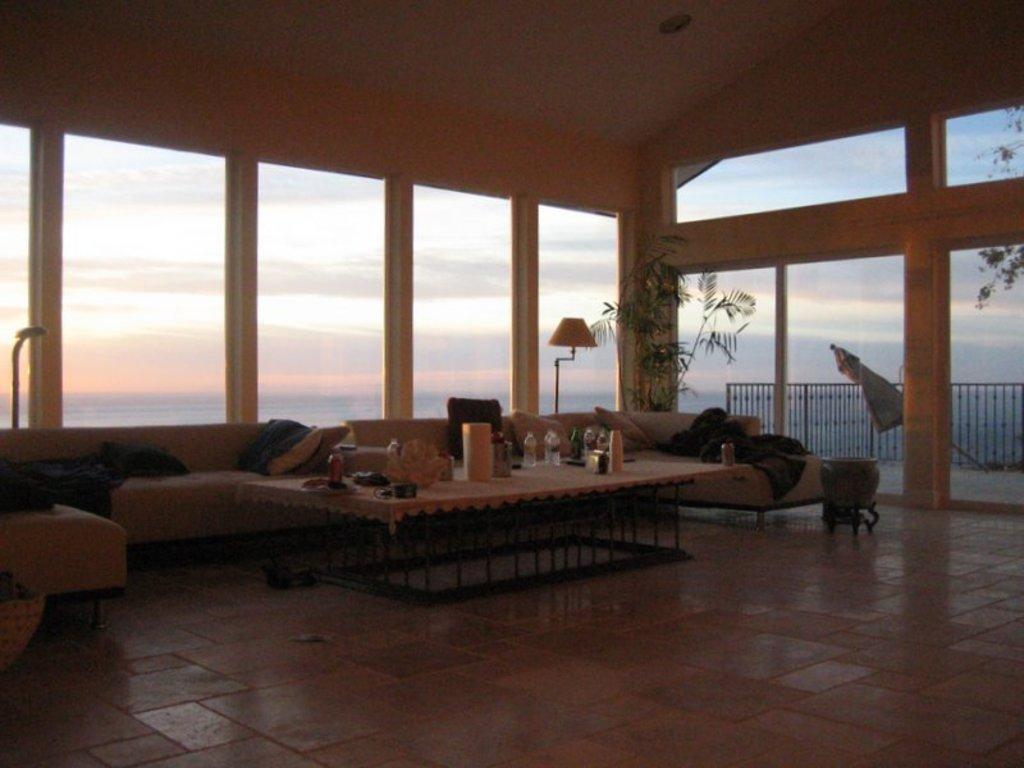How would you summarize this image in a sentence or two? This is inside a building. There are sofas with pillows. Also there is a table. On the table there are bottles and many other items. In the back there is a plant. Also there are pillars. On the right side there is a railing. In the background there is sky. 